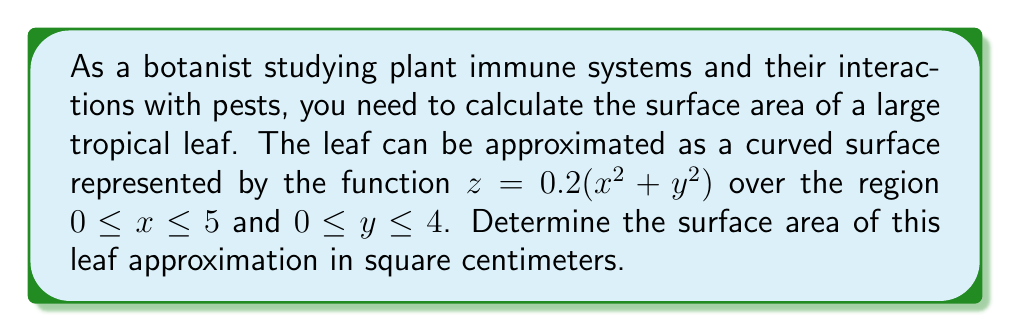Teach me how to tackle this problem. To find the surface area of a curved surface represented by a function $z = f(x,y)$, we use the surface area formula:

$$ A = \int\int_R \sqrt{1 + \left(\frac{\partial z}{\partial x}\right)^2 + \left(\frac{\partial z}{\partial y}\right)^2} \, dA $$

Where $R$ is the region of integration.

Steps:
1) First, we need to find the partial derivatives:
   $\frac{\partial z}{\partial x} = 0.4x$
   $\frac{\partial z}{\partial y} = 0.4y$

2) Substitute these into the surface area formula:
   $$ A = \int_0^4 \int_0^5 \sqrt{1 + (0.4x)^2 + (0.4y)^2} \, dx \, dy $$

3) Simplify the integrand:
   $$ A = \int_0^4 \int_0^5 \sqrt{1 + 0.16x^2 + 0.16y^2} \, dx \, dy $$

4) This integral is difficult to evaluate analytically, so we'll use numerical integration. Using a computer algebra system or numerical integration tool, we can evaluate this double integral.

5) The result of the numerical integration is approximately 22.6735 square centimeters.

[asy]
import graph3;
size(200,200,IgnoreAspect);
currentprojection=perspective(6,3,2);
limits((0,0,0),(5,4,2));

triple f(pair t) {return (t.x,t.y,0.2*(t.x^2+t.y^2));}
surface s=surface(f,(0,0),(5,4),20,20,Spline);
draw(s,palegreen);

xaxis3("$x$",Arrow3);
yaxis3("$y$",Arrow3);
zaxis3("$z$",Arrow3);
[/asy]
Answer: The surface area of the leaf approximation is approximately 22.67 cm². 